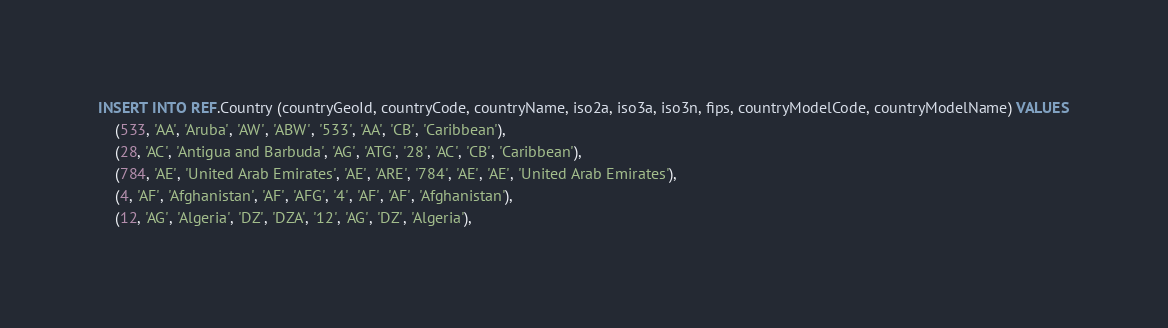Convert code to text. <code><loc_0><loc_0><loc_500><loc_500><_SQL_>INSERT INTO REF.Country (countryGeoId, countryCode, countryName, iso2a, iso3a, iso3n, fips, countryModelCode, countryModelName) VALUES
    (533, 'AA', 'Aruba', 'AW', 'ABW', '533', 'AA', 'CB', 'Caribbean'),
    (28, 'AC', 'Antigua and Barbuda', 'AG', 'ATG', '28', 'AC', 'CB', 'Caribbean'),
    (784, 'AE', 'United Arab Emirates', 'AE', 'ARE', '784', 'AE', 'AE', 'United Arab Emirates'),
    (4, 'AF', 'Afghanistan', 'AF', 'AFG', '4', 'AF', 'AF', 'Afghanistan'),
    (12, 'AG', 'Algeria', 'DZ', 'DZA', '12', 'AG', 'DZ', 'Algeria'),</code> 